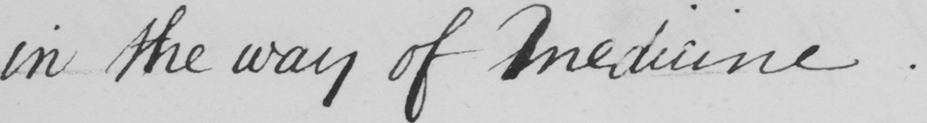Can you read and transcribe this handwriting? in the way of Medicine . 